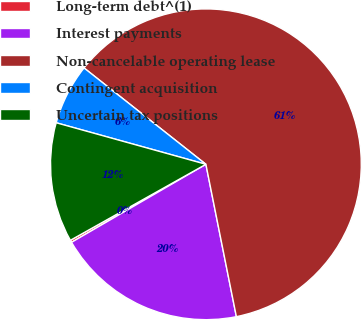<chart> <loc_0><loc_0><loc_500><loc_500><pie_chart><fcel>Long-term debt^(1)<fcel>Interest payments<fcel>Non-cancelable operating lease<fcel>Contingent acquisition<fcel>Uncertain tax positions<nl><fcel>0.24%<fcel>19.77%<fcel>61.21%<fcel>6.34%<fcel>12.44%<nl></chart> 